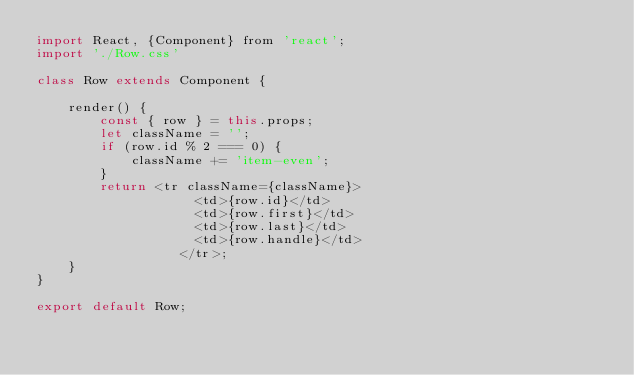Convert code to text. <code><loc_0><loc_0><loc_500><loc_500><_JavaScript_>import React, {Component} from 'react';
import './Row.css'

class Row extends Component {
    
    render() {
        const { row } = this.props;
        let className = '';
        if (row.id % 2 === 0) {
            className += 'item-even';
        }
        return <tr className={className}>
                    <td>{row.id}</td>
                    <td>{row.first}</td>
                    <td>{row.last}</td>
                    <td>{row.handle}</td>
                  </tr>;
    }
}

export default Row;</code> 